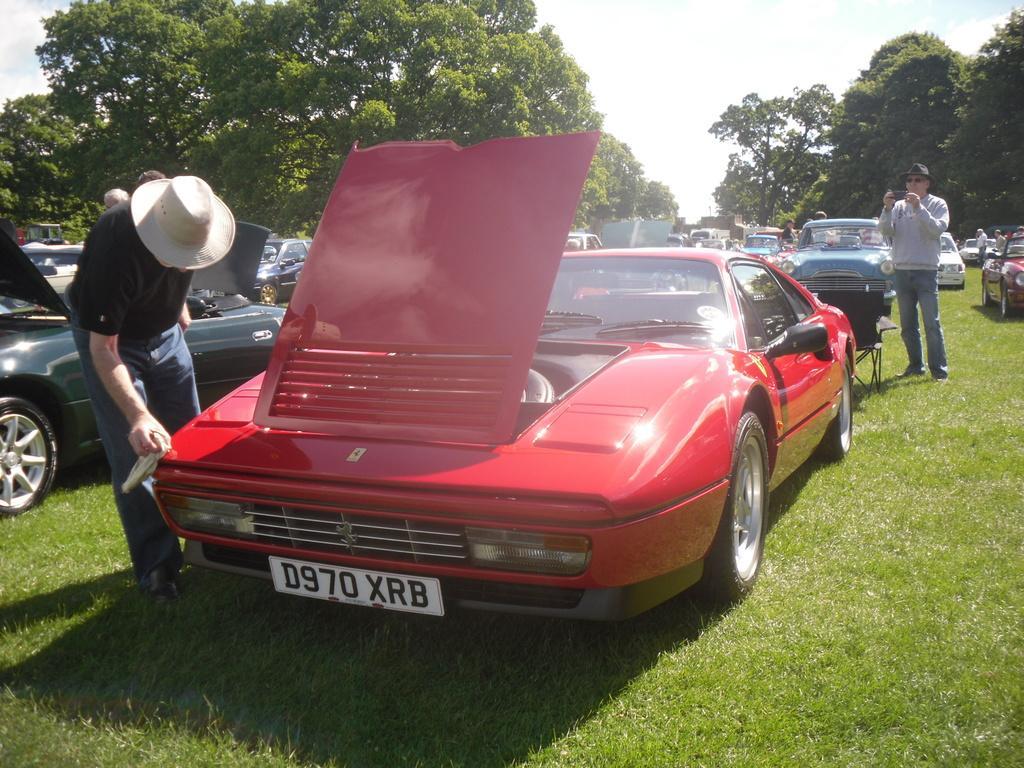Can you describe this image briefly? In this image, we can see so many vehicles are parked on the grass. Here a person is clean a car with cloth and wearing a hat. On the right side, a person is holding an object and wearing a hat and goggles. Background there are so many trees, people and sky. 